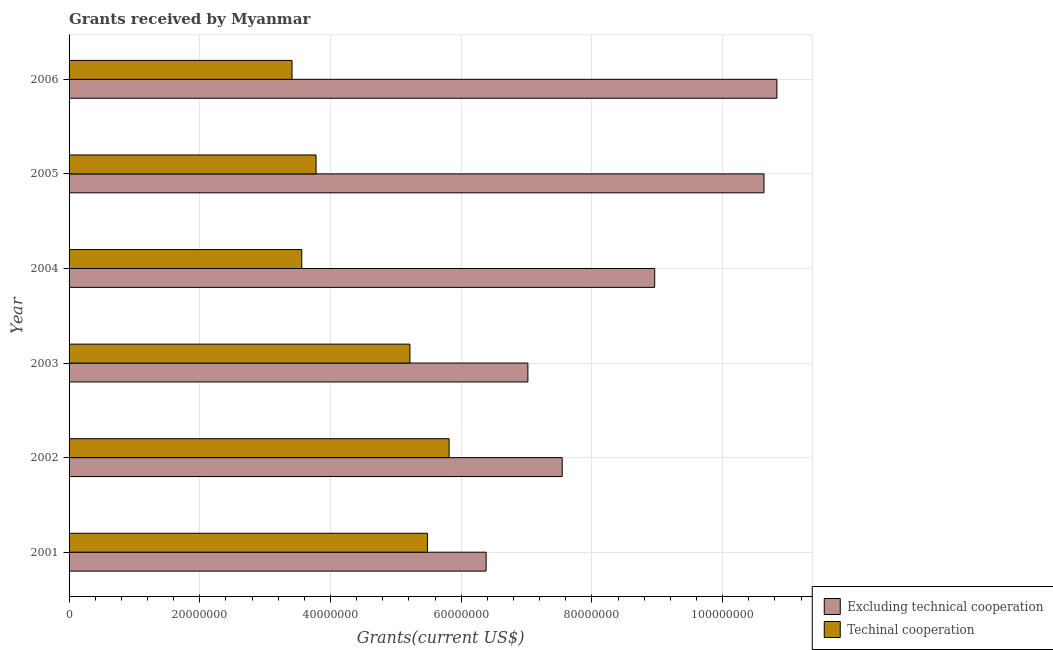Are the number of bars on each tick of the Y-axis equal?
Your answer should be very brief. Yes. How many bars are there on the 6th tick from the bottom?
Your answer should be compact. 2. What is the label of the 3rd group of bars from the top?
Ensure brevity in your answer.  2004. In how many cases, is the number of bars for a given year not equal to the number of legend labels?
Offer a very short reply. 0. What is the amount of grants received(including technical cooperation) in 2003?
Your response must be concise. 5.22e+07. Across all years, what is the maximum amount of grants received(excluding technical cooperation)?
Ensure brevity in your answer.  1.08e+08. Across all years, what is the minimum amount of grants received(including technical cooperation)?
Offer a very short reply. 3.41e+07. In which year was the amount of grants received(including technical cooperation) maximum?
Keep it short and to the point. 2002. In which year was the amount of grants received(including technical cooperation) minimum?
Provide a succinct answer. 2006. What is the total amount of grants received(including technical cooperation) in the graph?
Give a very brief answer. 2.73e+08. What is the difference between the amount of grants received(excluding technical cooperation) in 2003 and that in 2006?
Provide a short and direct response. -3.81e+07. What is the difference between the amount of grants received(excluding technical cooperation) in 2005 and the amount of grants received(including technical cooperation) in 2001?
Offer a very short reply. 5.15e+07. What is the average amount of grants received(including technical cooperation) per year?
Offer a very short reply. 4.54e+07. In the year 2002, what is the difference between the amount of grants received(including technical cooperation) and amount of grants received(excluding technical cooperation)?
Ensure brevity in your answer.  -1.73e+07. What is the ratio of the amount of grants received(excluding technical cooperation) in 2003 to that in 2004?
Provide a short and direct response. 0.78. Is the amount of grants received(including technical cooperation) in 2005 less than that in 2006?
Offer a very short reply. No. What is the difference between the highest and the second highest amount of grants received(excluding technical cooperation)?
Make the answer very short. 1.97e+06. What is the difference between the highest and the lowest amount of grants received(including technical cooperation)?
Offer a terse response. 2.40e+07. What does the 1st bar from the top in 2005 represents?
Provide a succinct answer. Techinal cooperation. What does the 1st bar from the bottom in 2002 represents?
Make the answer very short. Excluding technical cooperation. Are all the bars in the graph horizontal?
Your response must be concise. Yes. How many years are there in the graph?
Provide a short and direct response. 6. Does the graph contain any zero values?
Keep it short and to the point. No. What is the title of the graph?
Keep it short and to the point. Grants received by Myanmar. Does "Study and work" appear as one of the legend labels in the graph?
Your answer should be compact. No. What is the label or title of the X-axis?
Offer a very short reply. Grants(current US$). What is the label or title of the Y-axis?
Ensure brevity in your answer.  Year. What is the Grants(current US$) in Excluding technical cooperation in 2001?
Provide a short and direct response. 6.38e+07. What is the Grants(current US$) of Techinal cooperation in 2001?
Offer a very short reply. 5.48e+07. What is the Grants(current US$) of Excluding technical cooperation in 2002?
Provide a succinct answer. 7.54e+07. What is the Grants(current US$) in Techinal cooperation in 2002?
Offer a very short reply. 5.82e+07. What is the Grants(current US$) of Excluding technical cooperation in 2003?
Provide a succinct answer. 7.02e+07. What is the Grants(current US$) of Techinal cooperation in 2003?
Offer a very short reply. 5.22e+07. What is the Grants(current US$) in Excluding technical cooperation in 2004?
Your response must be concise. 8.96e+07. What is the Grants(current US$) in Techinal cooperation in 2004?
Your answer should be very brief. 3.56e+07. What is the Grants(current US$) of Excluding technical cooperation in 2005?
Keep it short and to the point. 1.06e+08. What is the Grants(current US$) in Techinal cooperation in 2005?
Offer a terse response. 3.78e+07. What is the Grants(current US$) of Excluding technical cooperation in 2006?
Offer a very short reply. 1.08e+08. What is the Grants(current US$) of Techinal cooperation in 2006?
Your answer should be very brief. 3.41e+07. Across all years, what is the maximum Grants(current US$) of Excluding technical cooperation?
Keep it short and to the point. 1.08e+08. Across all years, what is the maximum Grants(current US$) of Techinal cooperation?
Ensure brevity in your answer.  5.82e+07. Across all years, what is the minimum Grants(current US$) of Excluding technical cooperation?
Provide a short and direct response. 6.38e+07. Across all years, what is the minimum Grants(current US$) of Techinal cooperation?
Provide a short and direct response. 3.41e+07. What is the total Grants(current US$) in Excluding technical cooperation in the graph?
Your response must be concise. 5.14e+08. What is the total Grants(current US$) in Techinal cooperation in the graph?
Your answer should be compact. 2.73e+08. What is the difference between the Grants(current US$) in Excluding technical cooperation in 2001 and that in 2002?
Keep it short and to the point. -1.16e+07. What is the difference between the Grants(current US$) of Techinal cooperation in 2001 and that in 2002?
Keep it short and to the point. -3.32e+06. What is the difference between the Grants(current US$) of Excluding technical cooperation in 2001 and that in 2003?
Offer a very short reply. -6.39e+06. What is the difference between the Grants(current US$) in Techinal cooperation in 2001 and that in 2003?
Give a very brief answer. 2.68e+06. What is the difference between the Grants(current US$) in Excluding technical cooperation in 2001 and that in 2004?
Make the answer very short. -2.58e+07. What is the difference between the Grants(current US$) of Techinal cooperation in 2001 and that in 2004?
Offer a terse response. 1.92e+07. What is the difference between the Grants(current US$) in Excluding technical cooperation in 2001 and that in 2005?
Make the answer very short. -4.25e+07. What is the difference between the Grants(current US$) in Techinal cooperation in 2001 and that in 2005?
Offer a very short reply. 1.70e+07. What is the difference between the Grants(current US$) in Excluding technical cooperation in 2001 and that in 2006?
Make the answer very short. -4.45e+07. What is the difference between the Grants(current US$) in Techinal cooperation in 2001 and that in 2006?
Make the answer very short. 2.07e+07. What is the difference between the Grants(current US$) in Excluding technical cooperation in 2002 and that in 2003?
Your answer should be compact. 5.25e+06. What is the difference between the Grants(current US$) of Techinal cooperation in 2002 and that in 2003?
Give a very brief answer. 6.00e+06. What is the difference between the Grants(current US$) in Excluding technical cooperation in 2002 and that in 2004?
Keep it short and to the point. -1.42e+07. What is the difference between the Grants(current US$) in Techinal cooperation in 2002 and that in 2004?
Keep it short and to the point. 2.26e+07. What is the difference between the Grants(current US$) in Excluding technical cooperation in 2002 and that in 2005?
Offer a terse response. -3.09e+07. What is the difference between the Grants(current US$) of Techinal cooperation in 2002 and that in 2005?
Offer a very short reply. 2.04e+07. What is the difference between the Grants(current US$) in Excluding technical cooperation in 2002 and that in 2006?
Your answer should be compact. -3.28e+07. What is the difference between the Grants(current US$) in Techinal cooperation in 2002 and that in 2006?
Give a very brief answer. 2.40e+07. What is the difference between the Grants(current US$) in Excluding technical cooperation in 2003 and that in 2004?
Your answer should be compact. -1.94e+07. What is the difference between the Grants(current US$) in Techinal cooperation in 2003 and that in 2004?
Provide a succinct answer. 1.66e+07. What is the difference between the Grants(current US$) in Excluding technical cooperation in 2003 and that in 2005?
Your response must be concise. -3.61e+07. What is the difference between the Grants(current US$) in Techinal cooperation in 2003 and that in 2005?
Offer a terse response. 1.44e+07. What is the difference between the Grants(current US$) of Excluding technical cooperation in 2003 and that in 2006?
Offer a very short reply. -3.81e+07. What is the difference between the Grants(current US$) of Techinal cooperation in 2003 and that in 2006?
Offer a terse response. 1.80e+07. What is the difference between the Grants(current US$) in Excluding technical cooperation in 2004 and that in 2005?
Give a very brief answer. -1.67e+07. What is the difference between the Grants(current US$) in Techinal cooperation in 2004 and that in 2005?
Your answer should be compact. -2.19e+06. What is the difference between the Grants(current US$) of Excluding technical cooperation in 2004 and that in 2006?
Your response must be concise. -1.87e+07. What is the difference between the Grants(current US$) of Techinal cooperation in 2004 and that in 2006?
Keep it short and to the point. 1.49e+06. What is the difference between the Grants(current US$) in Excluding technical cooperation in 2005 and that in 2006?
Provide a succinct answer. -1.97e+06. What is the difference between the Grants(current US$) of Techinal cooperation in 2005 and that in 2006?
Your response must be concise. 3.68e+06. What is the difference between the Grants(current US$) of Excluding technical cooperation in 2001 and the Grants(current US$) of Techinal cooperation in 2002?
Offer a very short reply. 5.66e+06. What is the difference between the Grants(current US$) in Excluding technical cooperation in 2001 and the Grants(current US$) in Techinal cooperation in 2003?
Your answer should be very brief. 1.17e+07. What is the difference between the Grants(current US$) of Excluding technical cooperation in 2001 and the Grants(current US$) of Techinal cooperation in 2004?
Make the answer very short. 2.82e+07. What is the difference between the Grants(current US$) of Excluding technical cooperation in 2001 and the Grants(current US$) of Techinal cooperation in 2005?
Your answer should be very brief. 2.60e+07. What is the difference between the Grants(current US$) of Excluding technical cooperation in 2001 and the Grants(current US$) of Techinal cooperation in 2006?
Make the answer very short. 2.97e+07. What is the difference between the Grants(current US$) in Excluding technical cooperation in 2002 and the Grants(current US$) in Techinal cooperation in 2003?
Your answer should be very brief. 2.33e+07. What is the difference between the Grants(current US$) of Excluding technical cooperation in 2002 and the Grants(current US$) of Techinal cooperation in 2004?
Your response must be concise. 3.98e+07. What is the difference between the Grants(current US$) of Excluding technical cooperation in 2002 and the Grants(current US$) of Techinal cooperation in 2005?
Your answer should be compact. 3.77e+07. What is the difference between the Grants(current US$) in Excluding technical cooperation in 2002 and the Grants(current US$) in Techinal cooperation in 2006?
Provide a short and direct response. 4.13e+07. What is the difference between the Grants(current US$) of Excluding technical cooperation in 2003 and the Grants(current US$) of Techinal cooperation in 2004?
Offer a terse response. 3.46e+07. What is the difference between the Grants(current US$) in Excluding technical cooperation in 2003 and the Grants(current US$) in Techinal cooperation in 2005?
Keep it short and to the point. 3.24e+07. What is the difference between the Grants(current US$) in Excluding technical cooperation in 2003 and the Grants(current US$) in Techinal cooperation in 2006?
Offer a terse response. 3.61e+07. What is the difference between the Grants(current US$) in Excluding technical cooperation in 2004 and the Grants(current US$) in Techinal cooperation in 2005?
Your response must be concise. 5.18e+07. What is the difference between the Grants(current US$) in Excluding technical cooperation in 2004 and the Grants(current US$) in Techinal cooperation in 2006?
Keep it short and to the point. 5.55e+07. What is the difference between the Grants(current US$) of Excluding technical cooperation in 2005 and the Grants(current US$) of Techinal cooperation in 2006?
Your answer should be compact. 7.22e+07. What is the average Grants(current US$) in Excluding technical cooperation per year?
Offer a very short reply. 8.56e+07. What is the average Grants(current US$) of Techinal cooperation per year?
Provide a short and direct response. 4.54e+07. In the year 2001, what is the difference between the Grants(current US$) in Excluding technical cooperation and Grants(current US$) in Techinal cooperation?
Offer a very short reply. 8.98e+06. In the year 2002, what is the difference between the Grants(current US$) in Excluding technical cooperation and Grants(current US$) in Techinal cooperation?
Give a very brief answer. 1.73e+07. In the year 2003, what is the difference between the Grants(current US$) of Excluding technical cooperation and Grants(current US$) of Techinal cooperation?
Keep it short and to the point. 1.80e+07. In the year 2004, what is the difference between the Grants(current US$) in Excluding technical cooperation and Grants(current US$) in Techinal cooperation?
Your answer should be compact. 5.40e+07. In the year 2005, what is the difference between the Grants(current US$) of Excluding technical cooperation and Grants(current US$) of Techinal cooperation?
Offer a terse response. 6.85e+07. In the year 2006, what is the difference between the Grants(current US$) in Excluding technical cooperation and Grants(current US$) in Techinal cooperation?
Your answer should be very brief. 7.42e+07. What is the ratio of the Grants(current US$) of Excluding technical cooperation in 2001 to that in 2002?
Give a very brief answer. 0.85. What is the ratio of the Grants(current US$) of Techinal cooperation in 2001 to that in 2002?
Provide a succinct answer. 0.94. What is the ratio of the Grants(current US$) in Excluding technical cooperation in 2001 to that in 2003?
Provide a succinct answer. 0.91. What is the ratio of the Grants(current US$) in Techinal cooperation in 2001 to that in 2003?
Ensure brevity in your answer.  1.05. What is the ratio of the Grants(current US$) in Excluding technical cooperation in 2001 to that in 2004?
Provide a succinct answer. 0.71. What is the ratio of the Grants(current US$) in Techinal cooperation in 2001 to that in 2004?
Offer a very short reply. 1.54. What is the ratio of the Grants(current US$) of Excluding technical cooperation in 2001 to that in 2005?
Provide a short and direct response. 0.6. What is the ratio of the Grants(current US$) of Techinal cooperation in 2001 to that in 2005?
Your response must be concise. 1.45. What is the ratio of the Grants(current US$) in Excluding technical cooperation in 2001 to that in 2006?
Keep it short and to the point. 0.59. What is the ratio of the Grants(current US$) in Techinal cooperation in 2001 to that in 2006?
Make the answer very short. 1.61. What is the ratio of the Grants(current US$) in Excluding technical cooperation in 2002 to that in 2003?
Make the answer very short. 1.07. What is the ratio of the Grants(current US$) of Techinal cooperation in 2002 to that in 2003?
Keep it short and to the point. 1.12. What is the ratio of the Grants(current US$) in Excluding technical cooperation in 2002 to that in 2004?
Provide a succinct answer. 0.84. What is the ratio of the Grants(current US$) of Techinal cooperation in 2002 to that in 2004?
Offer a terse response. 1.63. What is the ratio of the Grants(current US$) in Excluding technical cooperation in 2002 to that in 2005?
Offer a very short reply. 0.71. What is the ratio of the Grants(current US$) of Techinal cooperation in 2002 to that in 2005?
Your answer should be very brief. 1.54. What is the ratio of the Grants(current US$) of Excluding technical cooperation in 2002 to that in 2006?
Offer a terse response. 0.7. What is the ratio of the Grants(current US$) in Techinal cooperation in 2002 to that in 2006?
Make the answer very short. 1.7. What is the ratio of the Grants(current US$) of Excluding technical cooperation in 2003 to that in 2004?
Offer a very short reply. 0.78. What is the ratio of the Grants(current US$) in Techinal cooperation in 2003 to that in 2004?
Your answer should be compact. 1.46. What is the ratio of the Grants(current US$) of Excluding technical cooperation in 2003 to that in 2005?
Offer a very short reply. 0.66. What is the ratio of the Grants(current US$) of Techinal cooperation in 2003 to that in 2005?
Your answer should be very brief. 1.38. What is the ratio of the Grants(current US$) in Excluding technical cooperation in 2003 to that in 2006?
Make the answer very short. 0.65. What is the ratio of the Grants(current US$) of Techinal cooperation in 2003 to that in 2006?
Provide a short and direct response. 1.53. What is the ratio of the Grants(current US$) in Excluding technical cooperation in 2004 to that in 2005?
Keep it short and to the point. 0.84. What is the ratio of the Grants(current US$) in Techinal cooperation in 2004 to that in 2005?
Your answer should be very brief. 0.94. What is the ratio of the Grants(current US$) of Excluding technical cooperation in 2004 to that in 2006?
Give a very brief answer. 0.83. What is the ratio of the Grants(current US$) in Techinal cooperation in 2004 to that in 2006?
Make the answer very short. 1.04. What is the ratio of the Grants(current US$) of Excluding technical cooperation in 2005 to that in 2006?
Ensure brevity in your answer.  0.98. What is the ratio of the Grants(current US$) of Techinal cooperation in 2005 to that in 2006?
Your answer should be very brief. 1.11. What is the difference between the highest and the second highest Grants(current US$) of Excluding technical cooperation?
Give a very brief answer. 1.97e+06. What is the difference between the highest and the second highest Grants(current US$) of Techinal cooperation?
Ensure brevity in your answer.  3.32e+06. What is the difference between the highest and the lowest Grants(current US$) in Excluding technical cooperation?
Provide a succinct answer. 4.45e+07. What is the difference between the highest and the lowest Grants(current US$) in Techinal cooperation?
Offer a terse response. 2.40e+07. 